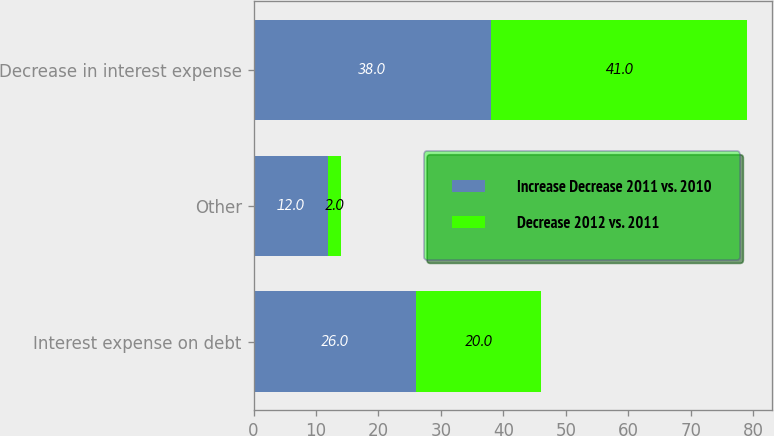Convert chart to OTSL. <chart><loc_0><loc_0><loc_500><loc_500><stacked_bar_chart><ecel><fcel>Interest expense on debt<fcel>Other<fcel>Decrease in interest expense<nl><fcel>Increase Decrease 2011 vs. 2010<fcel>26<fcel>12<fcel>38<nl><fcel>Decrease 2012 vs. 2011<fcel>20<fcel>2<fcel>41<nl></chart> 